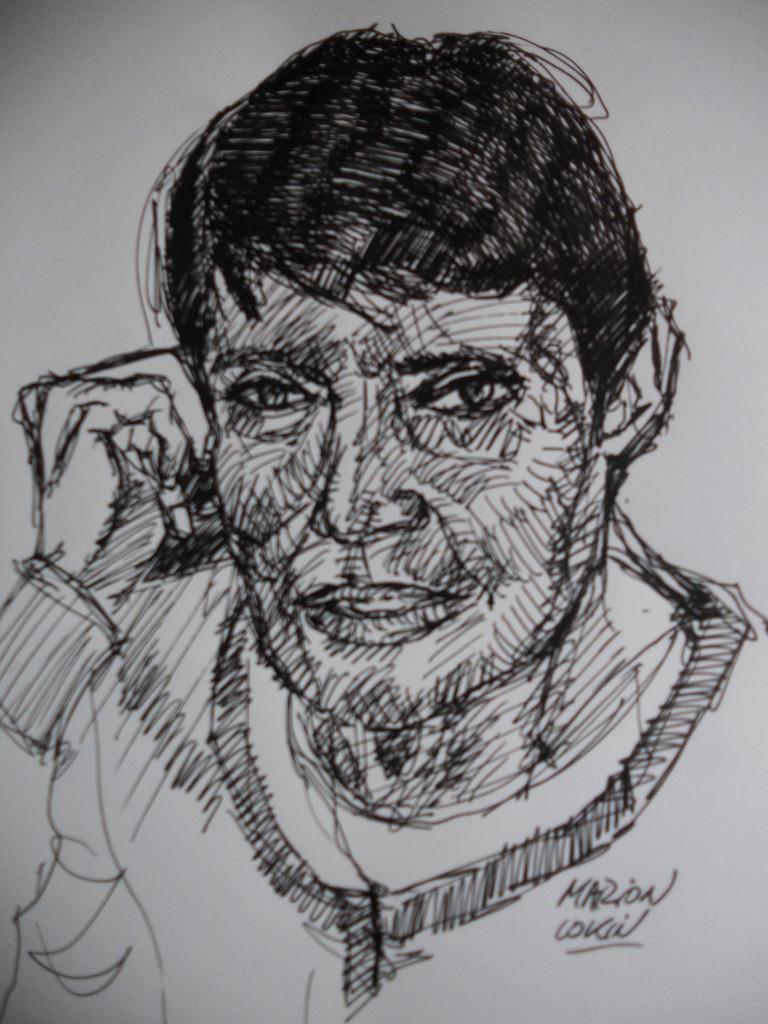What is the main subject of the image? There is a sketch in the image. What type of volleyball technique is being demonstrated in the sketch? There is no volleyball or any technique depicted in the sketch; it is a simple drawing. What observation can be made about the artist's style in the sketch? The provided facts do not give any information about the artist's style or any details about the sketch beyond its existence. 